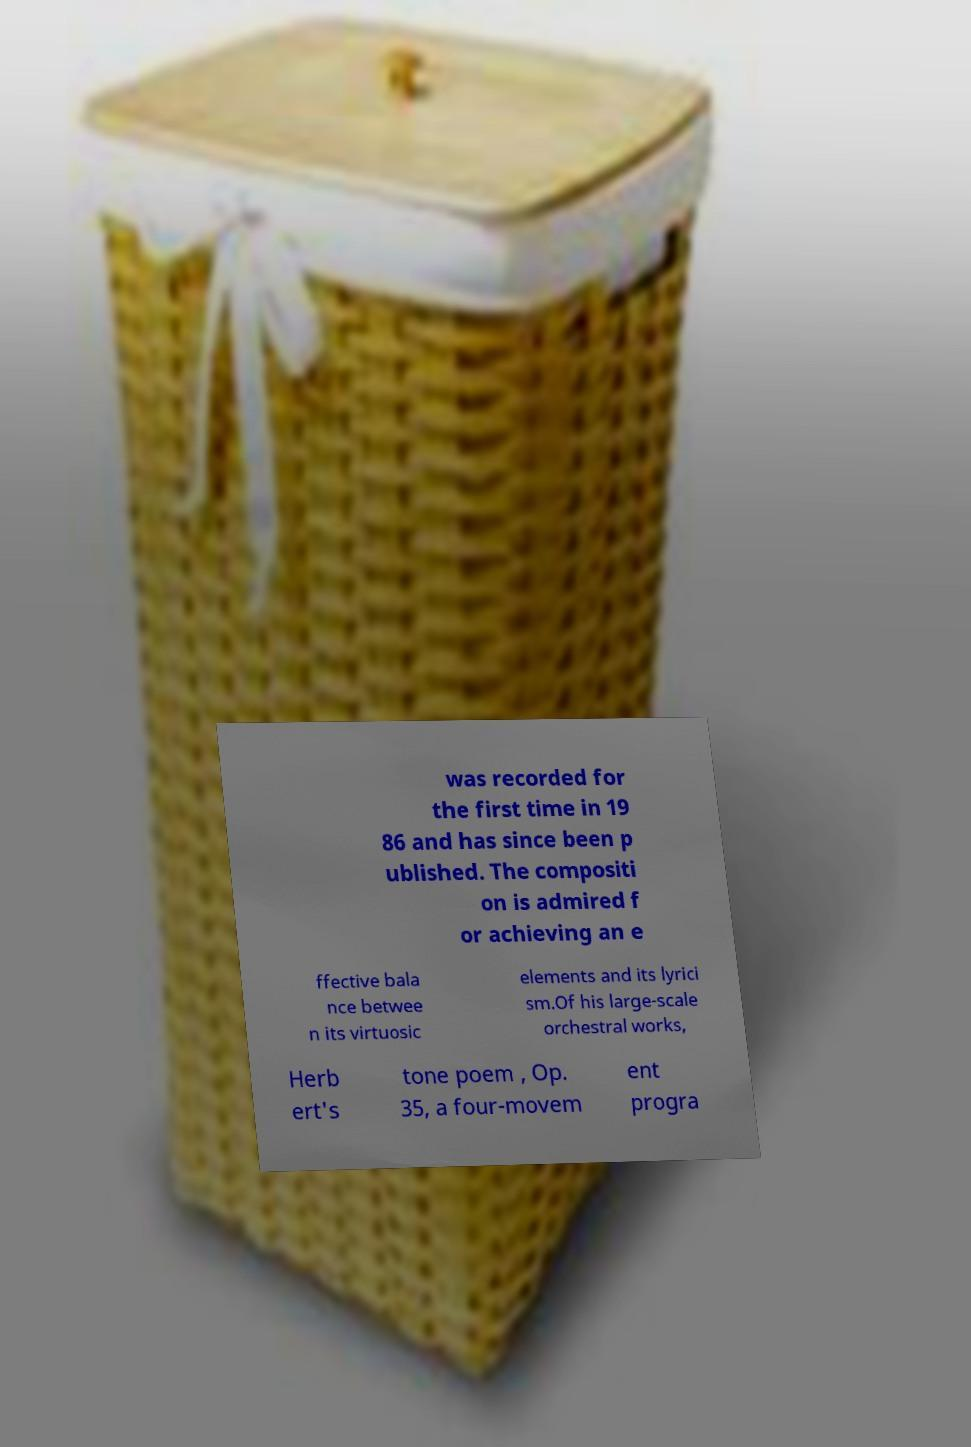Could you assist in decoding the text presented in this image and type it out clearly? was recorded for the first time in 19 86 and has since been p ublished. The compositi on is admired f or achieving an e ffective bala nce betwee n its virtuosic elements and its lyrici sm.Of his large-scale orchestral works, Herb ert's tone poem , Op. 35, a four-movem ent progra 